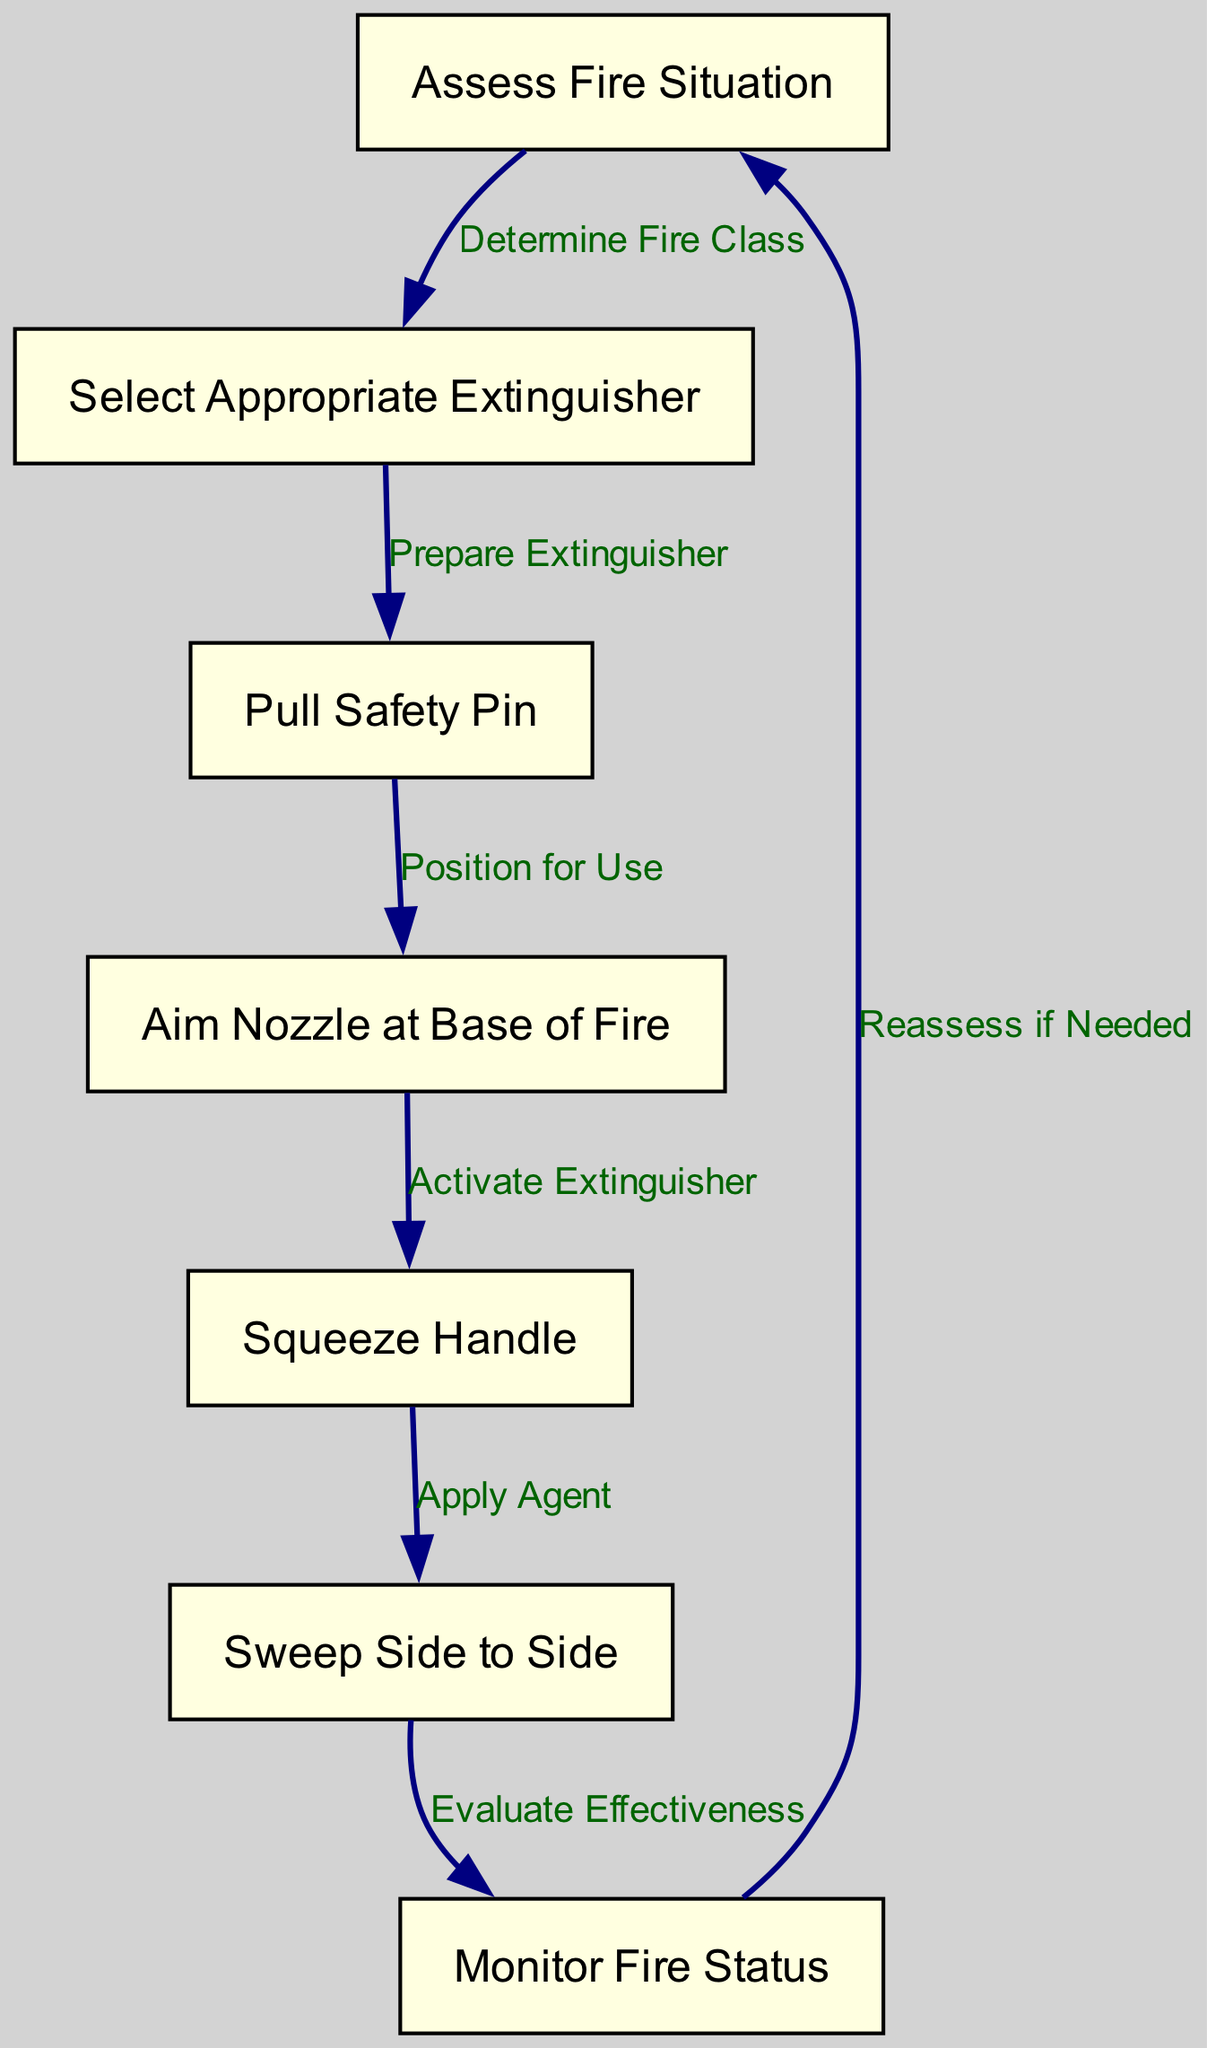What is the first step in the fire extinguisher operation process? The first step, represented by the first node in the diagram, is to "Assess Fire Situation."
Answer: Assess Fire Situation How many nodes are present in the diagram? The diagram contains a total of 7 nodes representing different steps in the fire extinguisher operation process.
Answer: 7 What action follows "Pull Safety Pin"? After "Pull Safety Pin," the next action in the process is "Aim Nozzle at Base of Fire," which is indicated by the directed edge leading from node 3 to node 4.
Answer: Aim Nozzle at Base of Fire What do you do after "Squeeze Handle"? After "Squeeze Handle," the next action is to "Sweep Side to Side," as indicated by the connection from node 5 to node 6 in the diagram.
Answer: Sweep Side to Side If you need to reassess the fire situation, which step do you go back to? If reassessment is needed, you go back to "Assess Fire Situation," which is represented by the directed edge from node 7 to node 1.
Answer: Assess Fire Situation What is the purpose of the step labeled "Monitor Fire Status"? The purpose of this step, shown as the last node before reassessment, is to evaluate whether the fire has been successfully controlled or extinguished, allowing for any necessary action to be taken.
Answer: Evaluate Effectiveness Which node indicates that you need to select the correct type of extinguisher? The node labeled "Select Appropriate Extinguisher" indicates the need to choose the correct type, following the assessment of the fire situation based on the connecting edge from node 1 to node 2.
Answer: Select Appropriate Extinguisher How do you apply the extinguishing agent? The extinguishing agent is applied by following the step "Squeeze Handle," allowing for the release of the agent, indicated in the flow from node 5 to node 6 labeled "Apply Agent."
Answer: Squeeze Handle What action comes after "Aim Nozzle at Base of Fire"? The action that comes after "Aim Nozzle at Base of Fire" is "Squeeze Handle," which is the next step indicated by the connection from node 4 to node 5.
Answer: Squeeze Handle 